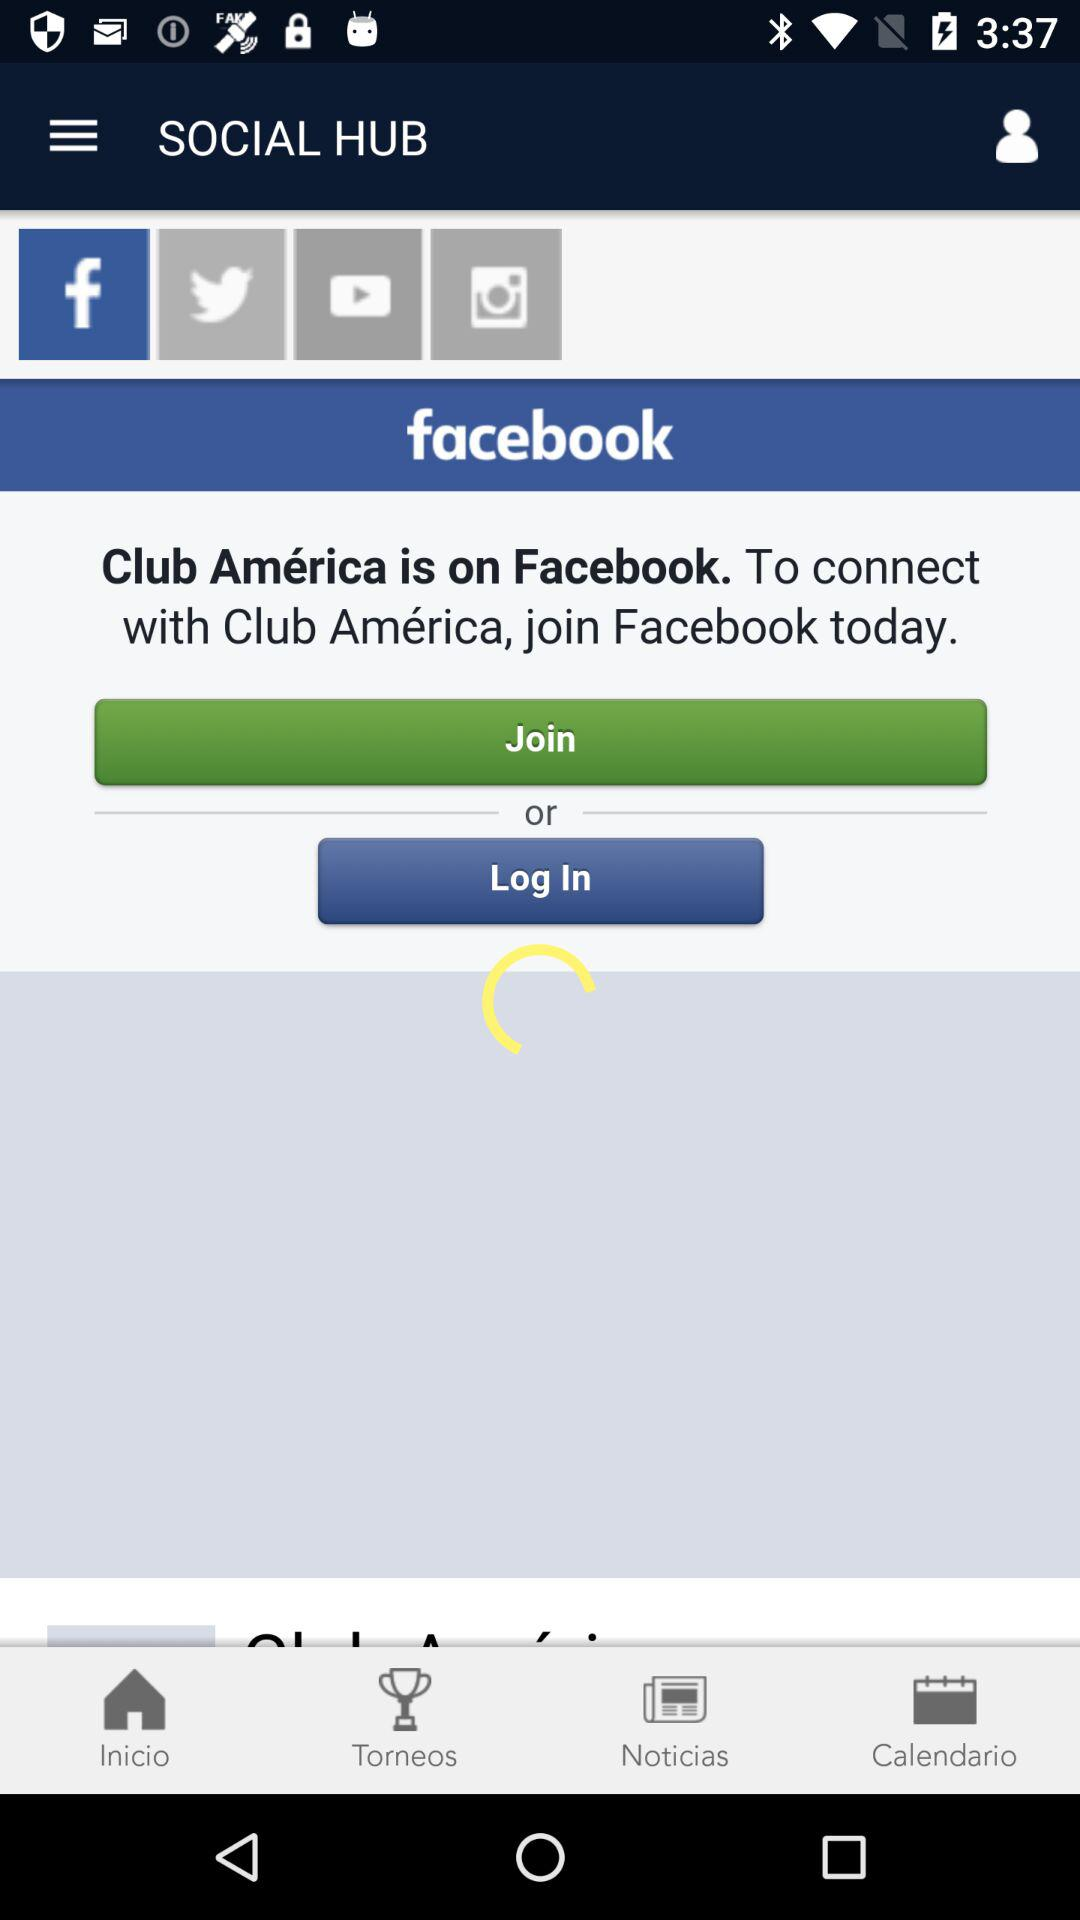What application is "Club América " on? The "Club América" is on "Facebook". 